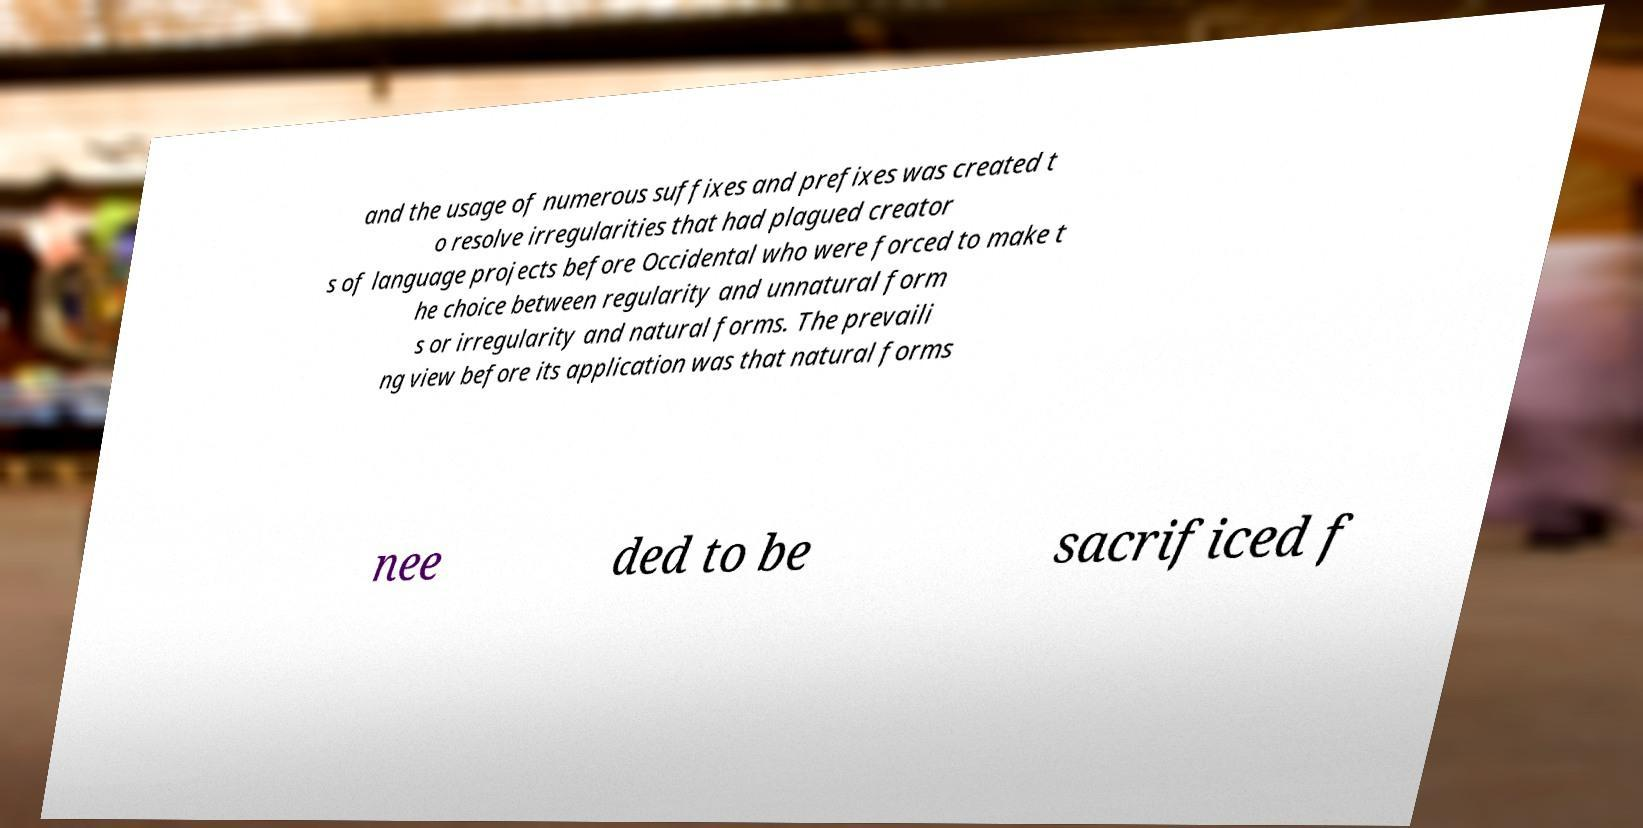I need the written content from this picture converted into text. Can you do that? and the usage of numerous suffixes and prefixes was created t o resolve irregularities that had plagued creator s of language projects before Occidental who were forced to make t he choice between regularity and unnatural form s or irregularity and natural forms. The prevaili ng view before its application was that natural forms nee ded to be sacrificed f 